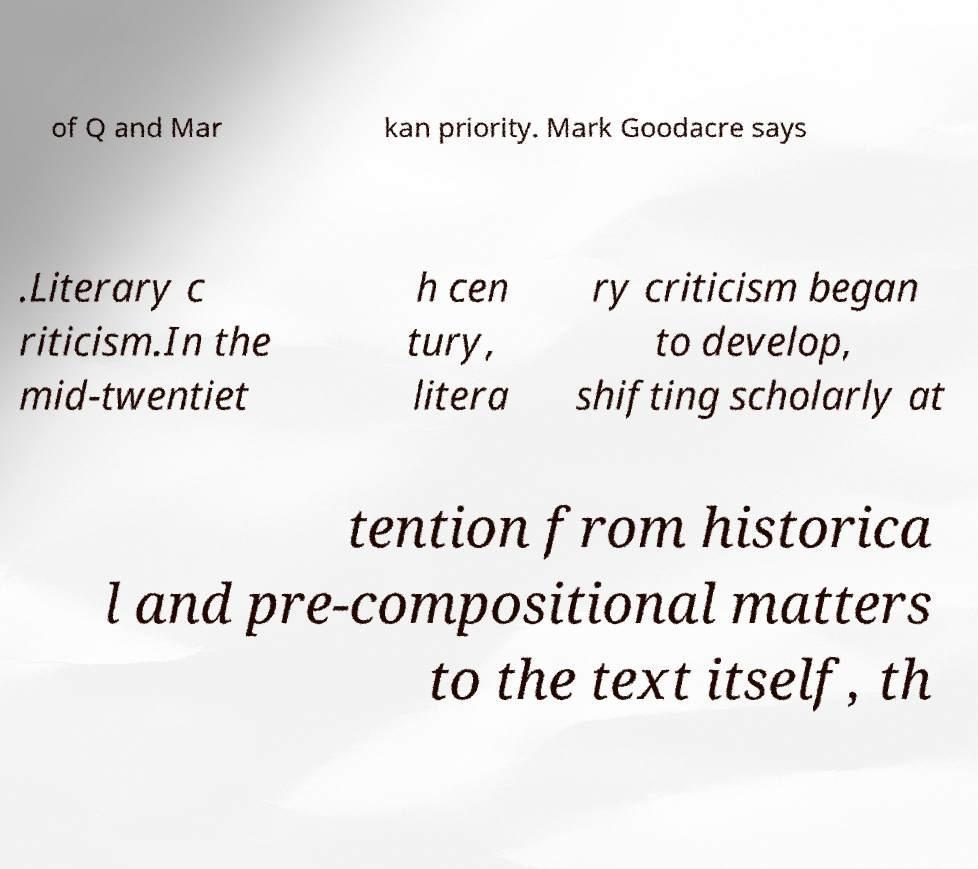What messages or text are displayed in this image? I need them in a readable, typed format. of Q and Mar kan priority. Mark Goodacre says .Literary c riticism.In the mid-twentiet h cen tury, litera ry criticism began to develop, shifting scholarly at tention from historica l and pre-compositional matters to the text itself, th 